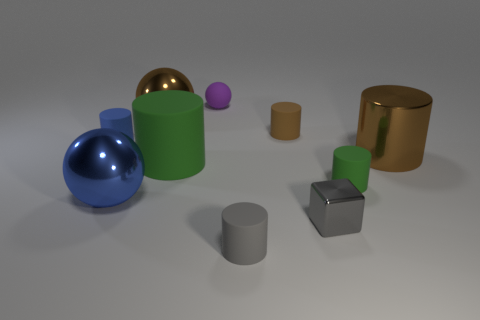The blue thing that is made of the same material as the brown ball is what shape?
Your answer should be very brief. Sphere. Are there fewer gray matte things than blue things?
Provide a short and direct response. Yes. What is the thing that is left of the cube and right of the gray matte cylinder made of?
Your response must be concise. Rubber. There is a brown metallic thing on the right side of the small gray object that is on the left side of the rubber cylinder that is behind the tiny blue rubber thing; how big is it?
Give a very brief answer. Large. Do the tiny blue rubber object and the large brown shiny thing in front of the small blue object have the same shape?
Offer a very short reply. Yes. How many small things are behind the blue metal thing and in front of the large green object?
Your answer should be very brief. 1. What number of yellow objects are either tiny cylinders or tiny metal cubes?
Keep it short and to the point. 0. There is a cylinder behind the small blue rubber cylinder; is it the same color as the matte object in front of the gray metal thing?
Offer a very short reply. No. What is the color of the small rubber cylinder to the left of the object that is behind the brown metal thing that is behind the blue rubber object?
Your answer should be very brief. Blue. There is a green thing that is right of the small gray metal object; is there a large shiny sphere behind it?
Offer a very short reply. Yes. 